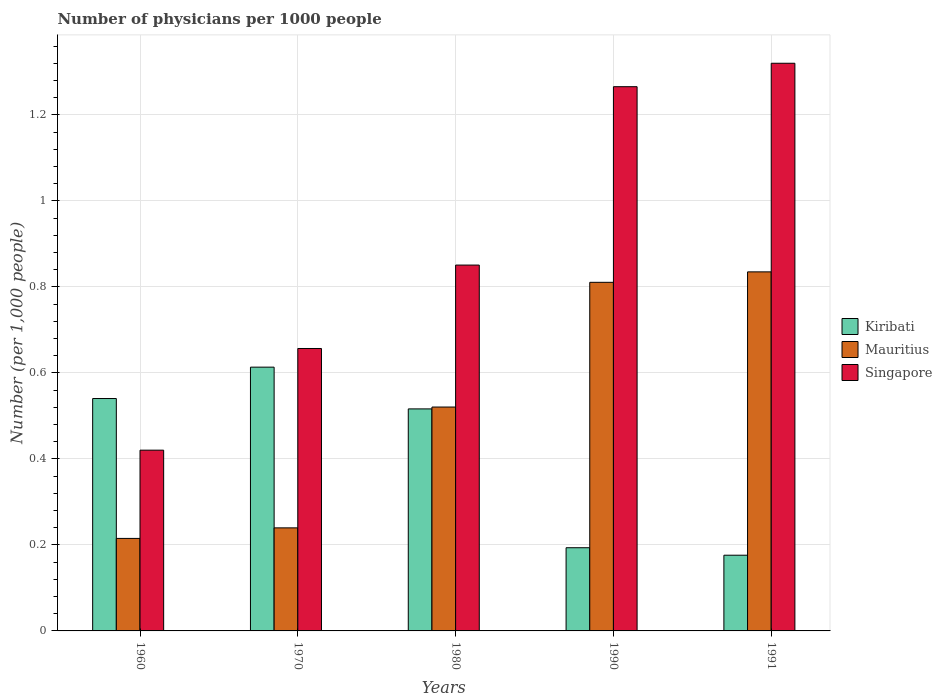Are the number of bars per tick equal to the number of legend labels?
Offer a very short reply. Yes. How many bars are there on the 4th tick from the right?
Make the answer very short. 3. What is the label of the 3rd group of bars from the left?
Keep it short and to the point. 1980. What is the number of physicians in Singapore in 1970?
Ensure brevity in your answer.  0.66. Across all years, what is the maximum number of physicians in Mauritius?
Offer a very short reply. 0.84. Across all years, what is the minimum number of physicians in Mauritius?
Make the answer very short. 0.22. In which year was the number of physicians in Singapore maximum?
Offer a very short reply. 1991. In which year was the number of physicians in Singapore minimum?
Ensure brevity in your answer.  1960. What is the total number of physicians in Mauritius in the graph?
Offer a terse response. 2.62. What is the difference between the number of physicians in Singapore in 1970 and that in 1980?
Make the answer very short. -0.19. What is the difference between the number of physicians in Singapore in 1991 and the number of physicians in Kiribati in 1960?
Your response must be concise. 0.78. What is the average number of physicians in Singapore per year?
Offer a terse response. 0.9. In the year 1980, what is the difference between the number of physicians in Singapore and number of physicians in Kiribati?
Provide a succinct answer. 0.33. What is the ratio of the number of physicians in Singapore in 1960 to that in 1990?
Keep it short and to the point. 0.33. What is the difference between the highest and the second highest number of physicians in Singapore?
Make the answer very short. 0.05. What is the difference between the highest and the lowest number of physicians in Kiribati?
Make the answer very short. 0.44. In how many years, is the number of physicians in Singapore greater than the average number of physicians in Singapore taken over all years?
Offer a terse response. 2. Is the sum of the number of physicians in Singapore in 1970 and 1990 greater than the maximum number of physicians in Kiribati across all years?
Your answer should be very brief. Yes. What does the 1st bar from the left in 1980 represents?
Give a very brief answer. Kiribati. What does the 2nd bar from the right in 1980 represents?
Offer a terse response. Mauritius. Is it the case that in every year, the sum of the number of physicians in Kiribati and number of physicians in Mauritius is greater than the number of physicians in Singapore?
Ensure brevity in your answer.  No. Are all the bars in the graph horizontal?
Offer a terse response. No. What is the difference between two consecutive major ticks on the Y-axis?
Ensure brevity in your answer.  0.2. Does the graph contain any zero values?
Provide a short and direct response. No. Does the graph contain grids?
Offer a terse response. Yes. Where does the legend appear in the graph?
Provide a short and direct response. Center right. How many legend labels are there?
Offer a terse response. 3. How are the legend labels stacked?
Provide a short and direct response. Vertical. What is the title of the graph?
Provide a short and direct response. Number of physicians per 1000 people. What is the label or title of the X-axis?
Your answer should be compact. Years. What is the label or title of the Y-axis?
Provide a succinct answer. Number (per 1,0 people). What is the Number (per 1,000 people) in Kiribati in 1960?
Keep it short and to the point. 0.54. What is the Number (per 1,000 people) of Mauritius in 1960?
Provide a short and direct response. 0.22. What is the Number (per 1,000 people) of Singapore in 1960?
Offer a very short reply. 0.42. What is the Number (per 1,000 people) in Kiribati in 1970?
Provide a short and direct response. 0.61. What is the Number (per 1,000 people) of Mauritius in 1970?
Provide a succinct answer. 0.24. What is the Number (per 1,000 people) of Singapore in 1970?
Your answer should be compact. 0.66. What is the Number (per 1,000 people) in Kiribati in 1980?
Provide a short and direct response. 0.52. What is the Number (per 1,000 people) in Mauritius in 1980?
Provide a succinct answer. 0.52. What is the Number (per 1,000 people) in Singapore in 1980?
Offer a very short reply. 0.85. What is the Number (per 1,000 people) of Kiribati in 1990?
Make the answer very short. 0.19. What is the Number (per 1,000 people) in Mauritius in 1990?
Offer a terse response. 0.81. What is the Number (per 1,000 people) in Singapore in 1990?
Give a very brief answer. 1.27. What is the Number (per 1,000 people) in Kiribati in 1991?
Make the answer very short. 0.18. What is the Number (per 1,000 people) in Mauritius in 1991?
Keep it short and to the point. 0.84. What is the Number (per 1,000 people) of Singapore in 1991?
Your response must be concise. 1.32. Across all years, what is the maximum Number (per 1,000 people) in Kiribati?
Your response must be concise. 0.61. Across all years, what is the maximum Number (per 1,000 people) of Mauritius?
Your response must be concise. 0.84. Across all years, what is the maximum Number (per 1,000 people) of Singapore?
Your response must be concise. 1.32. Across all years, what is the minimum Number (per 1,000 people) of Kiribati?
Your response must be concise. 0.18. Across all years, what is the minimum Number (per 1,000 people) in Mauritius?
Keep it short and to the point. 0.22. Across all years, what is the minimum Number (per 1,000 people) of Singapore?
Your response must be concise. 0.42. What is the total Number (per 1,000 people) in Kiribati in the graph?
Keep it short and to the point. 2.04. What is the total Number (per 1,000 people) of Mauritius in the graph?
Make the answer very short. 2.62. What is the total Number (per 1,000 people) in Singapore in the graph?
Offer a terse response. 4.51. What is the difference between the Number (per 1,000 people) of Kiribati in 1960 and that in 1970?
Your answer should be compact. -0.07. What is the difference between the Number (per 1,000 people) of Mauritius in 1960 and that in 1970?
Your answer should be compact. -0.02. What is the difference between the Number (per 1,000 people) in Singapore in 1960 and that in 1970?
Ensure brevity in your answer.  -0.24. What is the difference between the Number (per 1,000 people) of Kiribati in 1960 and that in 1980?
Keep it short and to the point. 0.02. What is the difference between the Number (per 1,000 people) of Mauritius in 1960 and that in 1980?
Provide a succinct answer. -0.31. What is the difference between the Number (per 1,000 people) of Singapore in 1960 and that in 1980?
Offer a very short reply. -0.43. What is the difference between the Number (per 1,000 people) of Kiribati in 1960 and that in 1990?
Your response must be concise. 0.35. What is the difference between the Number (per 1,000 people) of Mauritius in 1960 and that in 1990?
Your response must be concise. -0.6. What is the difference between the Number (per 1,000 people) in Singapore in 1960 and that in 1990?
Offer a very short reply. -0.85. What is the difference between the Number (per 1,000 people) of Kiribati in 1960 and that in 1991?
Make the answer very short. 0.36. What is the difference between the Number (per 1,000 people) in Mauritius in 1960 and that in 1991?
Your answer should be compact. -0.62. What is the difference between the Number (per 1,000 people) of Singapore in 1960 and that in 1991?
Offer a terse response. -0.9. What is the difference between the Number (per 1,000 people) of Kiribati in 1970 and that in 1980?
Keep it short and to the point. 0.1. What is the difference between the Number (per 1,000 people) in Mauritius in 1970 and that in 1980?
Provide a short and direct response. -0.28. What is the difference between the Number (per 1,000 people) of Singapore in 1970 and that in 1980?
Offer a very short reply. -0.19. What is the difference between the Number (per 1,000 people) in Kiribati in 1970 and that in 1990?
Make the answer very short. 0.42. What is the difference between the Number (per 1,000 people) of Mauritius in 1970 and that in 1990?
Keep it short and to the point. -0.57. What is the difference between the Number (per 1,000 people) of Singapore in 1970 and that in 1990?
Give a very brief answer. -0.61. What is the difference between the Number (per 1,000 people) in Kiribati in 1970 and that in 1991?
Your response must be concise. 0.44. What is the difference between the Number (per 1,000 people) of Mauritius in 1970 and that in 1991?
Offer a very short reply. -0.6. What is the difference between the Number (per 1,000 people) in Singapore in 1970 and that in 1991?
Provide a succinct answer. -0.66. What is the difference between the Number (per 1,000 people) in Kiribati in 1980 and that in 1990?
Provide a succinct answer. 0.32. What is the difference between the Number (per 1,000 people) in Mauritius in 1980 and that in 1990?
Offer a very short reply. -0.29. What is the difference between the Number (per 1,000 people) in Singapore in 1980 and that in 1990?
Provide a succinct answer. -0.41. What is the difference between the Number (per 1,000 people) of Kiribati in 1980 and that in 1991?
Your answer should be very brief. 0.34. What is the difference between the Number (per 1,000 people) of Mauritius in 1980 and that in 1991?
Keep it short and to the point. -0.31. What is the difference between the Number (per 1,000 people) of Singapore in 1980 and that in 1991?
Give a very brief answer. -0.47. What is the difference between the Number (per 1,000 people) of Kiribati in 1990 and that in 1991?
Give a very brief answer. 0.02. What is the difference between the Number (per 1,000 people) in Mauritius in 1990 and that in 1991?
Provide a succinct answer. -0.02. What is the difference between the Number (per 1,000 people) in Singapore in 1990 and that in 1991?
Your answer should be very brief. -0.05. What is the difference between the Number (per 1,000 people) in Kiribati in 1960 and the Number (per 1,000 people) in Mauritius in 1970?
Your response must be concise. 0.3. What is the difference between the Number (per 1,000 people) in Kiribati in 1960 and the Number (per 1,000 people) in Singapore in 1970?
Provide a succinct answer. -0.12. What is the difference between the Number (per 1,000 people) in Mauritius in 1960 and the Number (per 1,000 people) in Singapore in 1970?
Keep it short and to the point. -0.44. What is the difference between the Number (per 1,000 people) in Kiribati in 1960 and the Number (per 1,000 people) in Mauritius in 1980?
Give a very brief answer. 0.02. What is the difference between the Number (per 1,000 people) in Kiribati in 1960 and the Number (per 1,000 people) in Singapore in 1980?
Your answer should be very brief. -0.31. What is the difference between the Number (per 1,000 people) of Mauritius in 1960 and the Number (per 1,000 people) of Singapore in 1980?
Offer a terse response. -0.64. What is the difference between the Number (per 1,000 people) in Kiribati in 1960 and the Number (per 1,000 people) in Mauritius in 1990?
Your response must be concise. -0.27. What is the difference between the Number (per 1,000 people) in Kiribati in 1960 and the Number (per 1,000 people) in Singapore in 1990?
Make the answer very short. -0.73. What is the difference between the Number (per 1,000 people) in Mauritius in 1960 and the Number (per 1,000 people) in Singapore in 1990?
Give a very brief answer. -1.05. What is the difference between the Number (per 1,000 people) in Kiribati in 1960 and the Number (per 1,000 people) in Mauritius in 1991?
Provide a short and direct response. -0.29. What is the difference between the Number (per 1,000 people) of Kiribati in 1960 and the Number (per 1,000 people) of Singapore in 1991?
Keep it short and to the point. -0.78. What is the difference between the Number (per 1,000 people) of Mauritius in 1960 and the Number (per 1,000 people) of Singapore in 1991?
Provide a succinct answer. -1.11. What is the difference between the Number (per 1,000 people) of Kiribati in 1970 and the Number (per 1,000 people) of Mauritius in 1980?
Your answer should be very brief. 0.09. What is the difference between the Number (per 1,000 people) of Kiribati in 1970 and the Number (per 1,000 people) of Singapore in 1980?
Offer a terse response. -0.24. What is the difference between the Number (per 1,000 people) of Mauritius in 1970 and the Number (per 1,000 people) of Singapore in 1980?
Your response must be concise. -0.61. What is the difference between the Number (per 1,000 people) of Kiribati in 1970 and the Number (per 1,000 people) of Mauritius in 1990?
Offer a very short reply. -0.2. What is the difference between the Number (per 1,000 people) of Kiribati in 1970 and the Number (per 1,000 people) of Singapore in 1990?
Keep it short and to the point. -0.65. What is the difference between the Number (per 1,000 people) in Mauritius in 1970 and the Number (per 1,000 people) in Singapore in 1990?
Your response must be concise. -1.03. What is the difference between the Number (per 1,000 people) of Kiribati in 1970 and the Number (per 1,000 people) of Mauritius in 1991?
Your response must be concise. -0.22. What is the difference between the Number (per 1,000 people) in Kiribati in 1970 and the Number (per 1,000 people) in Singapore in 1991?
Your answer should be compact. -0.71. What is the difference between the Number (per 1,000 people) of Mauritius in 1970 and the Number (per 1,000 people) of Singapore in 1991?
Your response must be concise. -1.08. What is the difference between the Number (per 1,000 people) of Kiribati in 1980 and the Number (per 1,000 people) of Mauritius in 1990?
Offer a terse response. -0.29. What is the difference between the Number (per 1,000 people) of Kiribati in 1980 and the Number (per 1,000 people) of Singapore in 1990?
Provide a short and direct response. -0.75. What is the difference between the Number (per 1,000 people) in Mauritius in 1980 and the Number (per 1,000 people) in Singapore in 1990?
Provide a succinct answer. -0.75. What is the difference between the Number (per 1,000 people) in Kiribati in 1980 and the Number (per 1,000 people) in Mauritius in 1991?
Ensure brevity in your answer.  -0.32. What is the difference between the Number (per 1,000 people) in Kiribati in 1980 and the Number (per 1,000 people) in Singapore in 1991?
Give a very brief answer. -0.8. What is the difference between the Number (per 1,000 people) in Mauritius in 1980 and the Number (per 1,000 people) in Singapore in 1991?
Provide a succinct answer. -0.8. What is the difference between the Number (per 1,000 people) of Kiribati in 1990 and the Number (per 1,000 people) of Mauritius in 1991?
Offer a terse response. -0.64. What is the difference between the Number (per 1,000 people) in Kiribati in 1990 and the Number (per 1,000 people) in Singapore in 1991?
Your answer should be compact. -1.13. What is the difference between the Number (per 1,000 people) of Mauritius in 1990 and the Number (per 1,000 people) of Singapore in 1991?
Your answer should be compact. -0.51. What is the average Number (per 1,000 people) in Kiribati per year?
Ensure brevity in your answer.  0.41. What is the average Number (per 1,000 people) in Mauritius per year?
Provide a succinct answer. 0.52. What is the average Number (per 1,000 people) of Singapore per year?
Offer a terse response. 0.9. In the year 1960, what is the difference between the Number (per 1,000 people) in Kiribati and Number (per 1,000 people) in Mauritius?
Provide a short and direct response. 0.33. In the year 1960, what is the difference between the Number (per 1,000 people) in Kiribati and Number (per 1,000 people) in Singapore?
Your response must be concise. 0.12. In the year 1960, what is the difference between the Number (per 1,000 people) in Mauritius and Number (per 1,000 people) in Singapore?
Provide a succinct answer. -0.21. In the year 1970, what is the difference between the Number (per 1,000 people) of Kiribati and Number (per 1,000 people) of Mauritius?
Offer a very short reply. 0.37. In the year 1970, what is the difference between the Number (per 1,000 people) of Kiribati and Number (per 1,000 people) of Singapore?
Provide a short and direct response. -0.04. In the year 1970, what is the difference between the Number (per 1,000 people) of Mauritius and Number (per 1,000 people) of Singapore?
Ensure brevity in your answer.  -0.42. In the year 1980, what is the difference between the Number (per 1,000 people) of Kiribati and Number (per 1,000 people) of Mauritius?
Give a very brief answer. -0. In the year 1980, what is the difference between the Number (per 1,000 people) in Kiribati and Number (per 1,000 people) in Singapore?
Offer a very short reply. -0.33. In the year 1980, what is the difference between the Number (per 1,000 people) in Mauritius and Number (per 1,000 people) in Singapore?
Offer a terse response. -0.33. In the year 1990, what is the difference between the Number (per 1,000 people) in Kiribati and Number (per 1,000 people) in Mauritius?
Offer a terse response. -0.62. In the year 1990, what is the difference between the Number (per 1,000 people) of Kiribati and Number (per 1,000 people) of Singapore?
Ensure brevity in your answer.  -1.07. In the year 1990, what is the difference between the Number (per 1,000 people) in Mauritius and Number (per 1,000 people) in Singapore?
Your answer should be very brief. -0.46. In the year 1991, what is the difference between the Number (per 1,000 people) in Kiribati and Number (per 1,000 people) in Mauritius?
Keep it short and to the point. -0.66. In the year 1991, what is the difference between the Number (per 1,000 people) in Kiribati and Number (per 1,000 people) in Singapore?
Provide a succinct answer. -1.14. In the year 1991, what is the difference between the Number (per 1,000 people) in Mauritius and Number (per 1,000 people) in Singapore?
Offer a terse response. -0.49. What is the ratio of the Number (per 1,000 people) of Kiribati in 1960 to that in 1970?
Provide a succinct answer. 0.88. What is the ratio of the Number (per 1,000 people) in Mauritius in 1960 to that in 1970?
Ensure brevity in your answer.  0.9. What is the ratio of the Number (per 1,000 people) of Singapore in 1960 to that in 1970?
Provide a succinct answer. 0.64. What is the ratio of the Number (per 1,000 people) of Kiribati in 1960 to that in 1980?
Offer a very short reply. 1.05. What is the ratio of the Number (per 1,000 people) in Mauritius in 1960 to that in 1980?
Offer a terse response. 0.41. What is the ratio of the Number (per 1,000 people) of Singapore in 1960 to that in 1980?
Provide a succinct answer. 0.49. What is the ratio of the Number (per 1,000 people) of Kiribati in 1960 to that in 1990?
Your answer should be compact. 2.79. What is the ratio of the Number (per 1,000 people) in Mauritius in 1960 to that in 1990?
Give a very brief answer. 0.27. What is the ratio of the Number (per 1,000 people) of Singapore in 1960 to that in 1990?
Give a very brief answer. 0.33. What is the ratio of the Number (per 1,000 people) in Kiribati in 1960 to that in 1991?
Your answer should be very brief. 3.07. What is the ratio of the Number (per 1,000 people) in Mauritius in 1960 to that in 1991?
Keep it short and to the point. 0.26. What is the ratio of the Number (per 1,000 people) of Singapore in 1960 to that in 1991?
Offer a terse response. 0.32. What is the ratio of the Number (per 1,000 people) in Kiribati in 1970 to that in 1980?
Your response must be concise. 1.19. What is the ratio of the Number (per 1,000 people) in Mauritius in 1970 to that in 1980?
Your answer should be very brief. 0.46. What is the ratio of the Number (per 1,000 people) of Singapore in 1970 to that in 1980?
Offer a very short reply. 0.77. What is the ratio of the Number (per 1,000 people) in Kiribati in 1970 to that in 1990?
Give a very brief answer. 3.17. What is the ratio of the Number (per 1,000 people) of Mauritius in 1970 to that in 1990?
Give a very brief answer. 0.3. What is the ratio of the Number (per 1,000 people) of Singapore in 1970 to that in 1990?
Provide a short and direct response. 0.52. What is the ratio of the Number (per 1,000 people) of Kiribati in 1970 to that in 1991?
Offer a very short reply. 3.48. What is the ratio of the Number (per 1,000 people) of Mauritius in 1970 to that in 1991?
Provide a succinct answer. 0.29. What is the ratio of the Number (per 1,000 people) in Singapore in 1970 to that in 1991?
Provide a short and direct response. 0.5. What is the ratio of the Number (per 1,000 people) in Kiribati in 1980 to that in 1990?
Keep it short and to the point. 2.67. What is the ratio of the Number (per 1,000 people) in Mauritius in 1980 to that in 1990?
Offer a terse response. 0.64. What is the ratio of the Number (per 1,000 people) in Singapore in 1980 to that in 1990?
Make the answer very short. 0.67. What is the ratio of the Number (per 1,000 people) of Kiribati in 1980 to that in 1991?
Provide a short and direct response. 2.93. What is the ratio of the Number (per 1,000 people) in Mauritius in 1980 to that in 1991?
Offer a very short reply. 0.62. What is the ratio of the Number (per 1,000 people) in Singapore in 1980 to that in 1991?
Provide a short and direct response. 0.64. What is the ratio of the Number (per 1,000 people) in Kiribati in 1990 to that in 1991?
Ensure brevity in your answer.  1.1. What is the ratio of the Number (per 1,000 people) in Mauritius in 1990 to that in 1991?
Offer a very short reply. 0.97. What is the ratio of the Number (per 1,000 people) in Singapore in 1990 to that in 1991?
Keep it short and to the point. 0.96. What is the difference between the highest and the second highest Number (per 1,000 people) in Kiribati?
Provide a succinct answer. 0.07. What is the difference between the highest and the second highest Number (per 1,000 people) of Mauritius?
Give a very brief answer. 0.02. What is the difference between the highest and the second highest Number (per 1,000 people) in Singapore?
Your answer should be compact. 0.05. What is the difference between the highest and the lowest Number (per 1,000 people) in Kiribati?
Ensure brevity in your answer.  0.44. What is the difference between the highest and the lowest Number (per 1,000 people) in Mauritius?
Your answer should be very brief. 0.62. What is the difference between the highest and the lowest Number (per 1,000 people) of Singapore?
Provide a short and direct response. 0.9. 